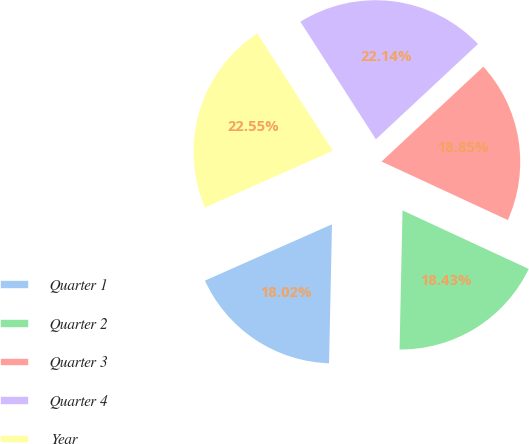Convert chart to OTSL. <chart><loc_0><loc_0><loc_500><loc_500><pie_chart><fcel>Quarter 1<fcel>Quarter 2<fcel>Quarter 3<fcel>Quarter 4<fcel>Year<nl><fcel>18.02%<fcel>18.43%<fcel>18.85%<fcel>22.14%<fcel>22.55%<nl></chart> 